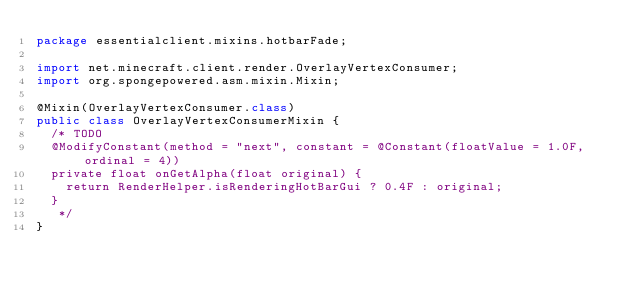<code> <loc_0><loc_0><loc_500><loc_500><_Java_>package essentialclient.mixins.hotbarFade;

import net.minecraft.client.render.OverlayVertexConsumer;
import org.spongepowered.asm.mixin.Mixin;

@Mixin(OverlayVertexConsumer.class)
public class OverlayVertexConsumerMixin {
	/* TODO
	@ModifyConstant(method = "next", constant = @Constant(floatValue = 1.0F, ordinal = 4))
	private float onGetAlpha(float original) {
		return RenderHelper.isRenderingHotBarGui ? 0.4F : original;
	}
	 */
}
</code> 